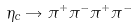<formula> <loc_0><loc_0><loc_500><loc_500>\eta _ { c } \rightarrow \pi ^ { + } \pi ^ { - } \pi ^ { + } \pi ^ { - }</formula> 